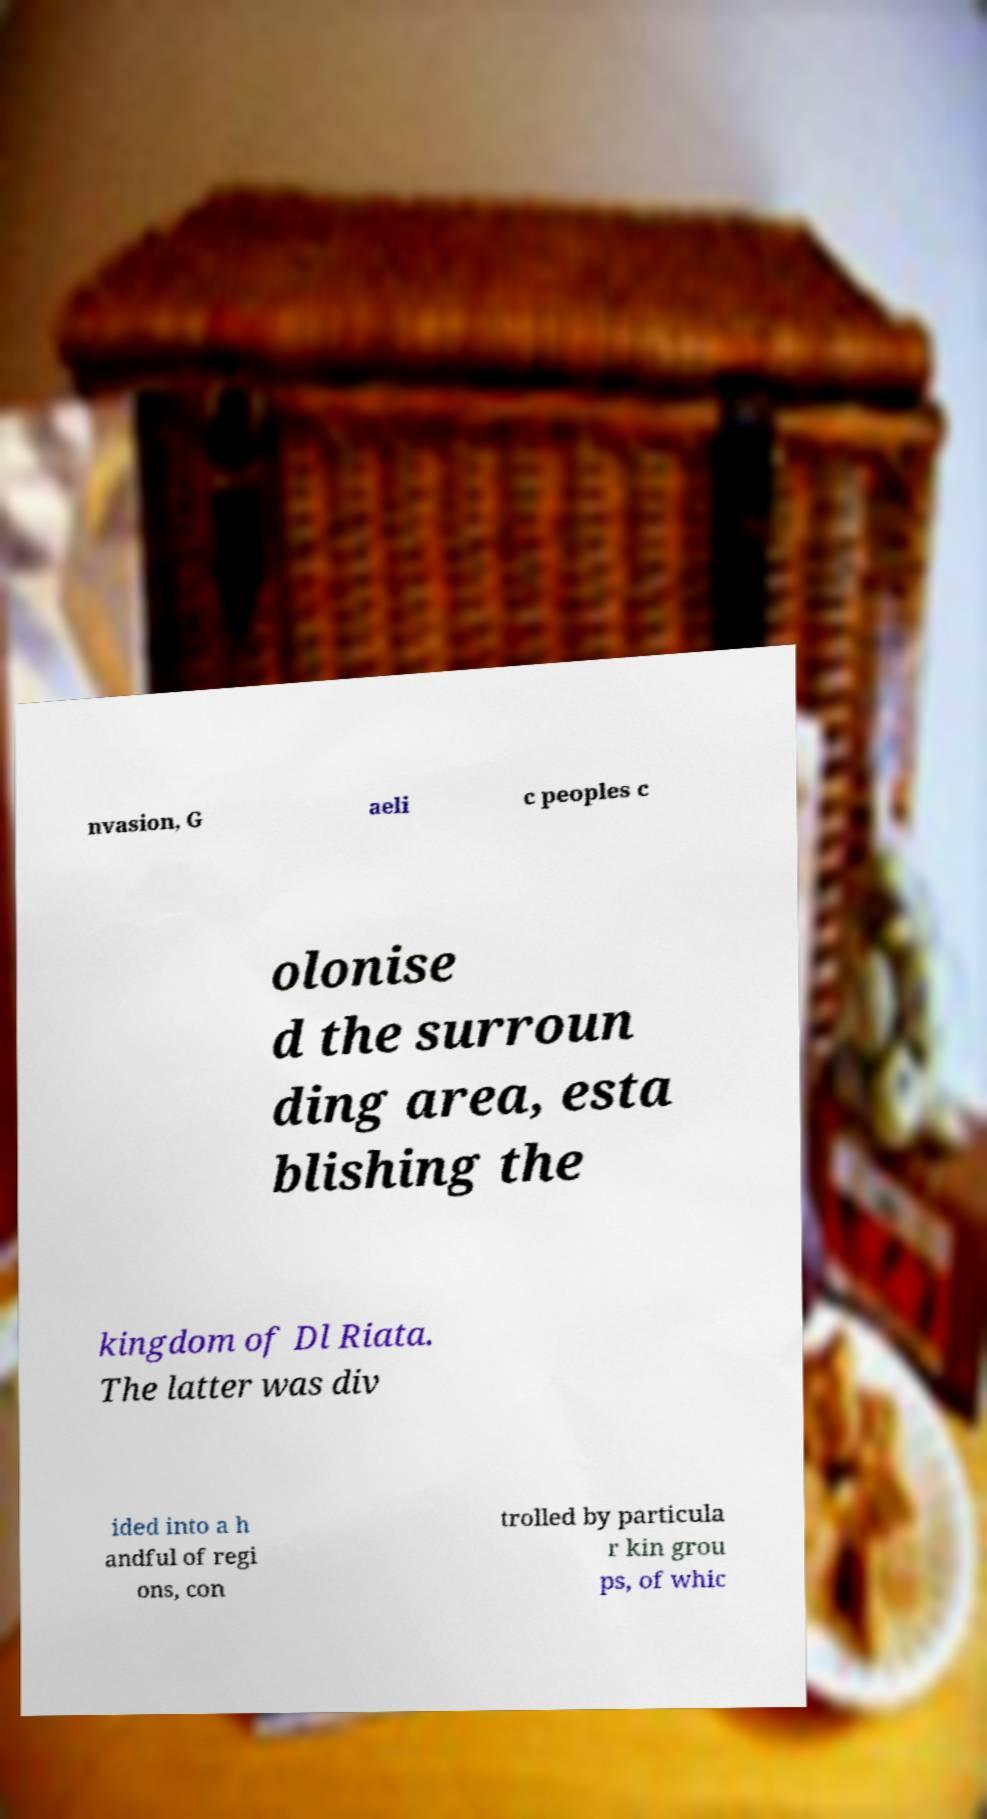I need the written content from this picture converted into text. Can you do that? nvasion, G aeli c peoples c olonise d the surroun ding area, esta blishing the kingdom of Dl Riata. The latter was div ided into a h andful of regi ons, con trolled by particula r kin grou ps, of whic 